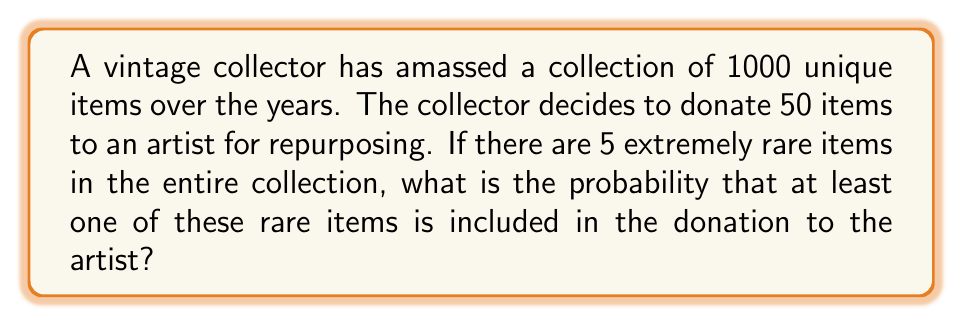Can you solve this math problem? To solve this problem, we'll use the complementary probability approach:

1) First, let's calculate the probability of not selecting any rare items in the donation.

2) The probability of not selecting a rare item on the first draw is:
   $$\frac{995}{1000} = 0.995$$

3) For the second draw, given that we didn't select a rare item on the first draw:
   $$\frac{994}{999} \approx 0.995$$

4) This continues for all 50 draws. The probability of not selecting any rare items in 50 draws is:
   $$P(\text{no rare items}) = \frac{995}{1000} \cdot \frac{994}{999} \cdot \frac{993}{998} \cdot ... \cdot \frac{946}{951}$$

5) This can be written more compactly using the combination formula:
   $$P(\text{no rare items}) = \frac{\binom{995}{50}}{\binom{1000}{50}}$$

6) Using a calculator or computer, we can compute this value:
   $$P(\text{no rare items}) \approx 0.7783$$

7) The probability of selecting at least one rare item is the complement of this probability:
   $$P(\text{at least one rare item}) = 1 - P(\text{no rare items})$$
   $$= 1 - 0.7783 = 0.2217$$

8) Therefore, the probability of including at least one rare item in the donation is approximately 0.2217 or 22.17%.
Answer: 0.2217 